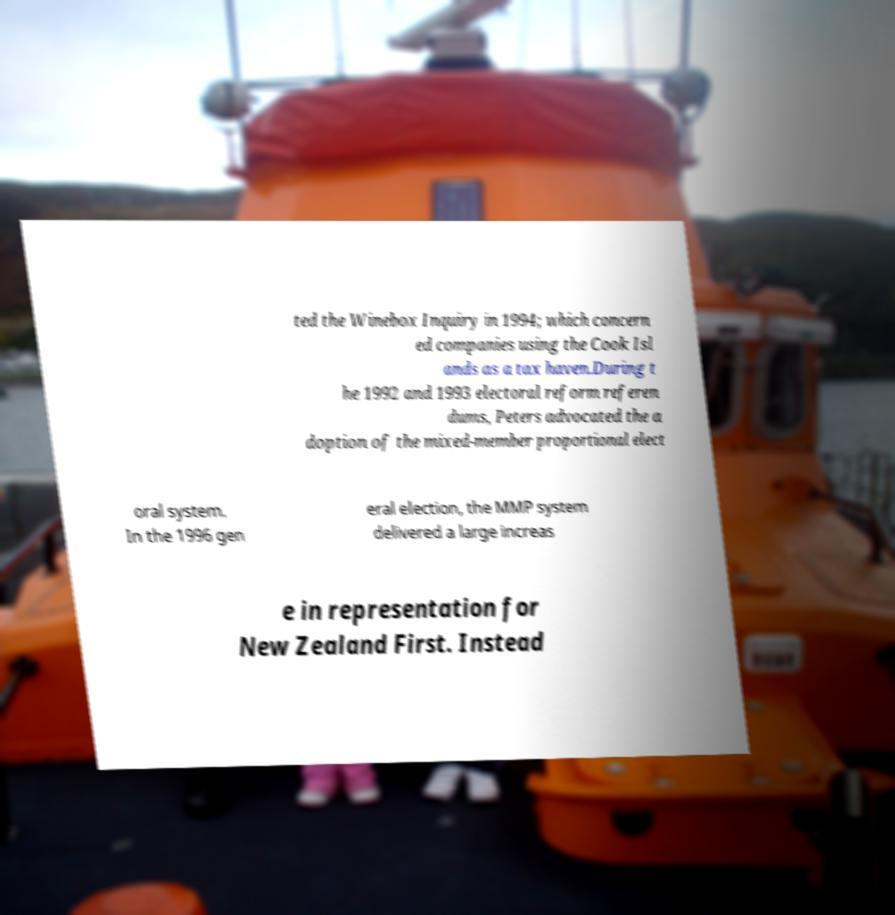There's text embedded in this image that I need extracted. Can you transcribe it verbatim? ted the Winebox Inquiry in 1994; which concern ed companies using the Cook Isl ands as a tax haven.During t he 1992 and 1993 electoral reform referen dums, Peters advocated the a doption of the mixed-member proportional elect oral system. In the 1996 gen eral election, the MMP system delivered a large increas e in representation for New Zealand First. Instead 